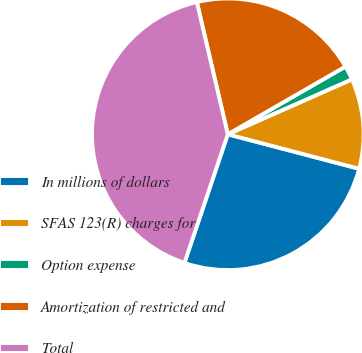Convert chart to OTSL. <chart><loc_0><loc_0><loc_500><loc_500><pie_chart><fcel>In millions of dollars<fcel>SFAS 123(R) charges for<fcel>Option expense<fcel>Amortization of restricted and<fcel>Total<nl><fcel>26.09%<fcel>10.72%<fcel>1.68%<fcel>20.35%<fcel>41.17%<nl></chart> 